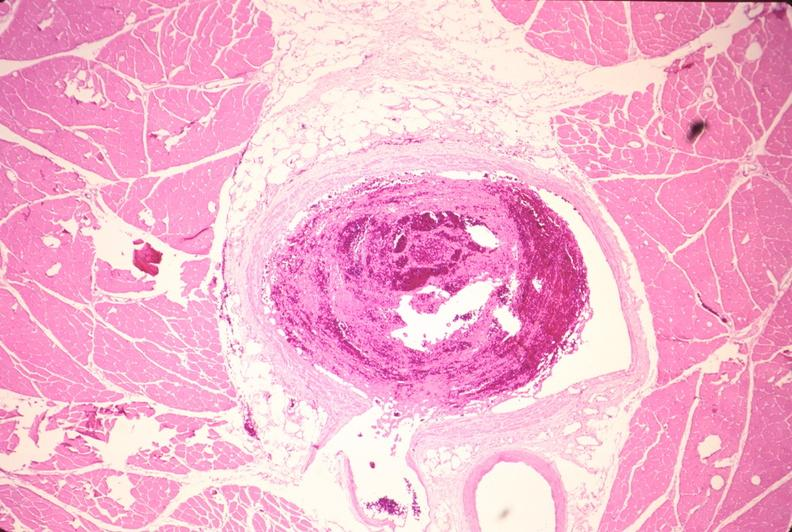s abdomen present?
Answer the question using a single word or phrase. No 